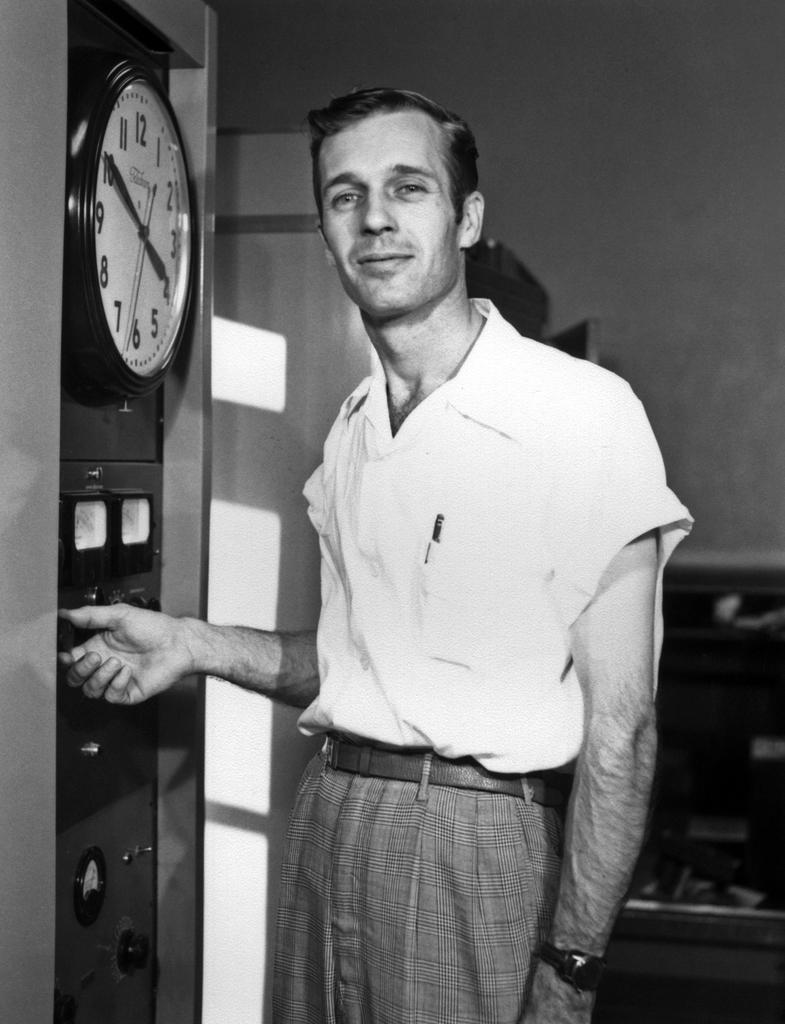<image>
Offer a succinct explanation of the picture presented. At ten minutes to four o'clock and man is adjusting a dial. 